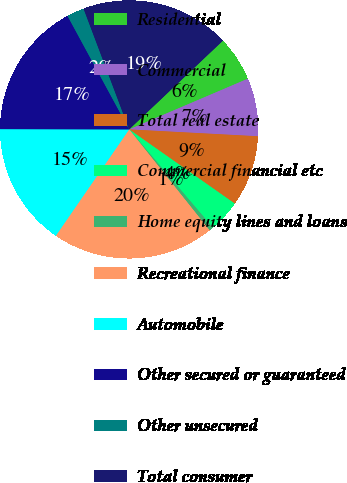Convert chart to OTSL. <chart><loc_0><loc_0><loc_500><loc_500><pie_chart><fcel>Residential<fcel>Commercial<fcel>Total real estate<fcel>Commercial financial etc<fcel>Home equity lines and loans<fcel>Recreational finance<fcel>Automobile<fcel>Other secured or guaranteed<fcel>Other unsecured<fcel>Total consumer<nl><fcel>5.64%<fcel>7.27%<fcel>8.9%<fcel>4.01%<fcel>0.53%<fcel>20.32%<fcel>15.42%<fcel>17.05%<fcel>2.17%<fcel>18.68%<nl></chart> 